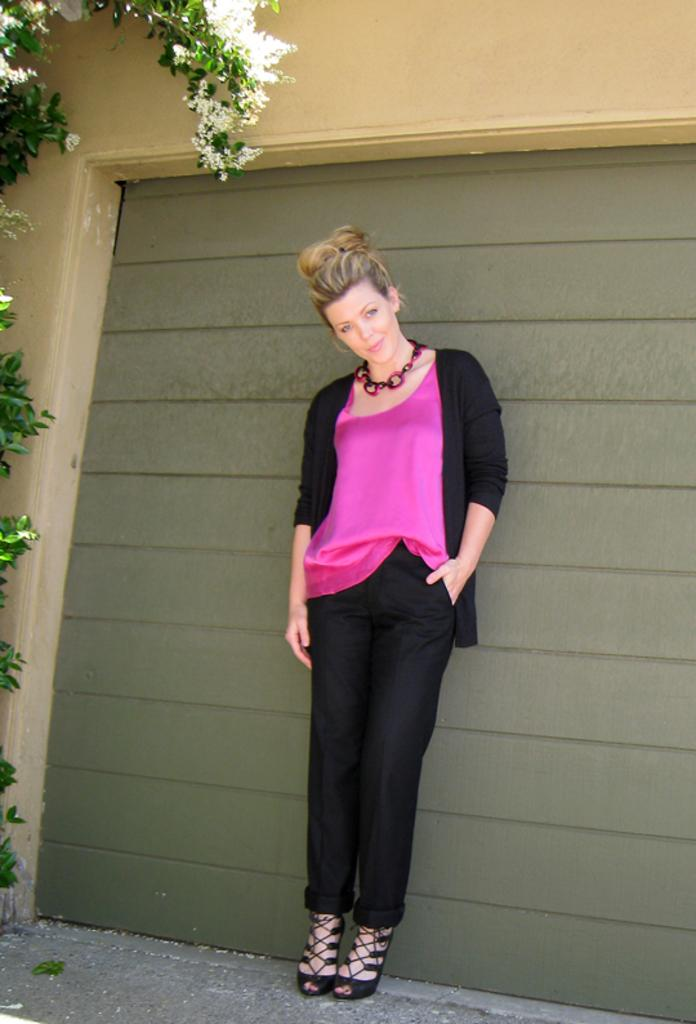Who or what is present in the image? There is a person in the image. What is the person wearing? The person is wearing clothes. Where is the person standing in relation to the wall? The person is standing in front of a wall. What can be seen on the left side of the image? There is a tree on the left side of the image. What type of letters does the person in the image have to order? There is no indication in the image that the person is ordering anything, let alone letters. 